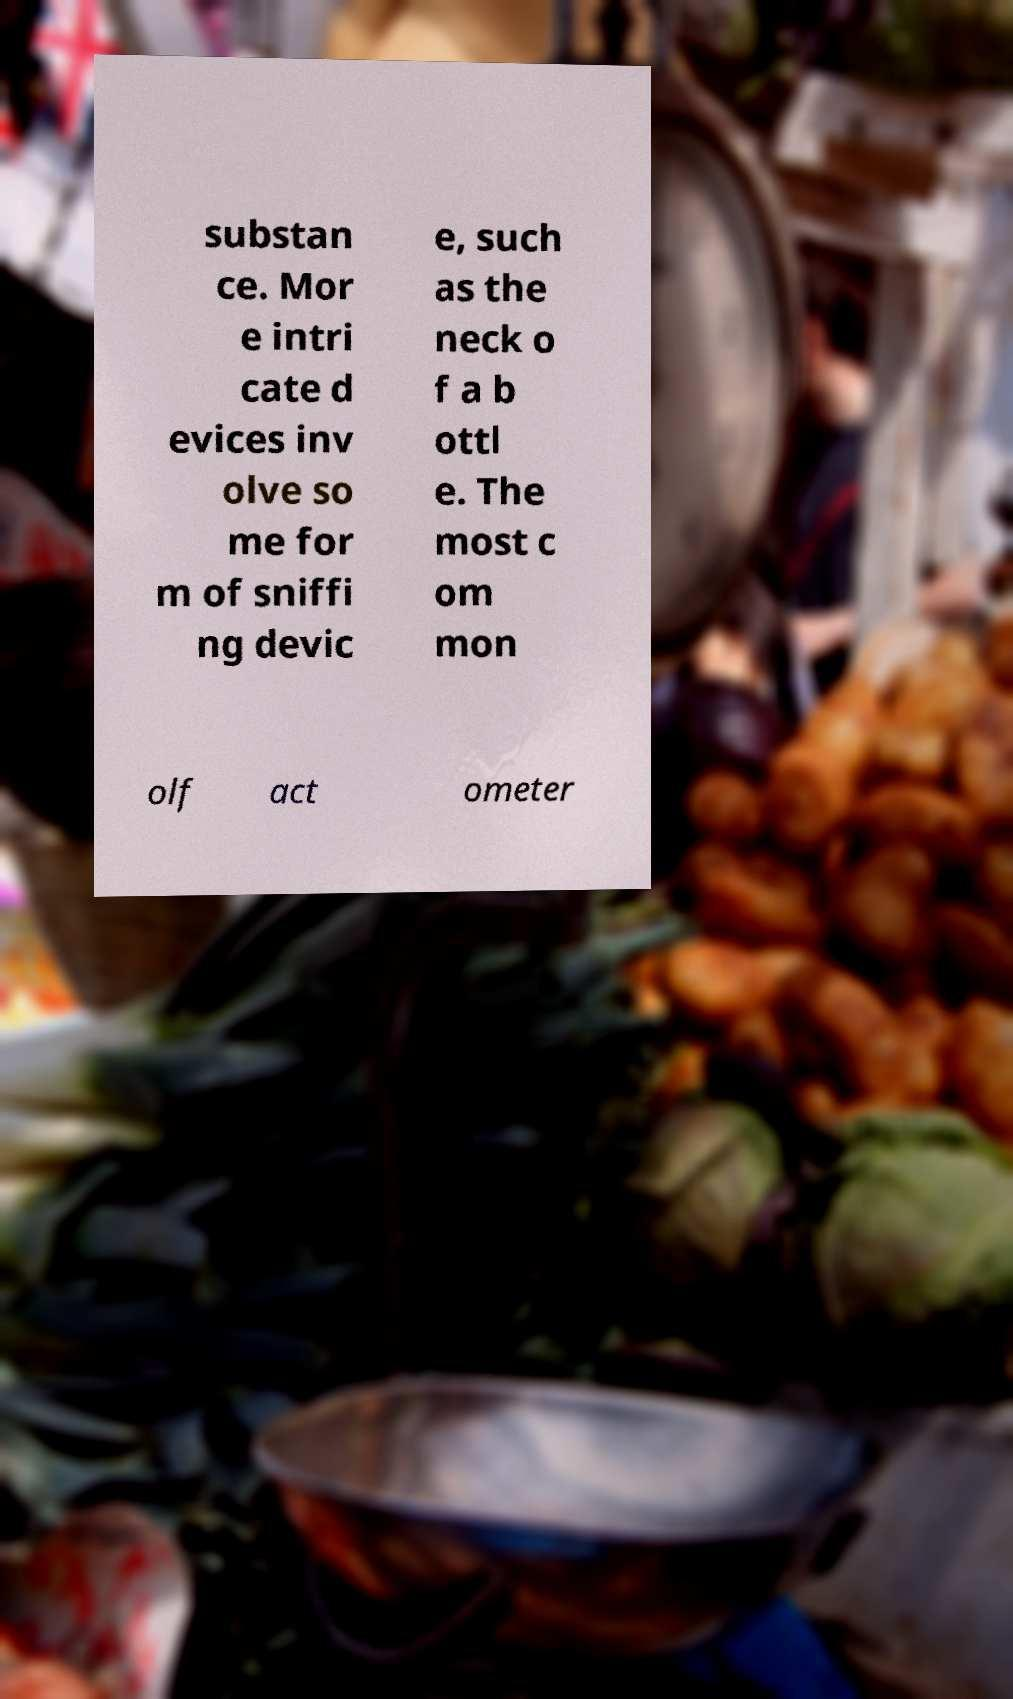For documentation purposes, I need the text within this image transcribed. Could you provide that? substan ce. Mor e intri cate d evices inv olve so me for m of sniffi ng devic e, such as the neck o f a b ottl e. The most c om mon olf act ometer 